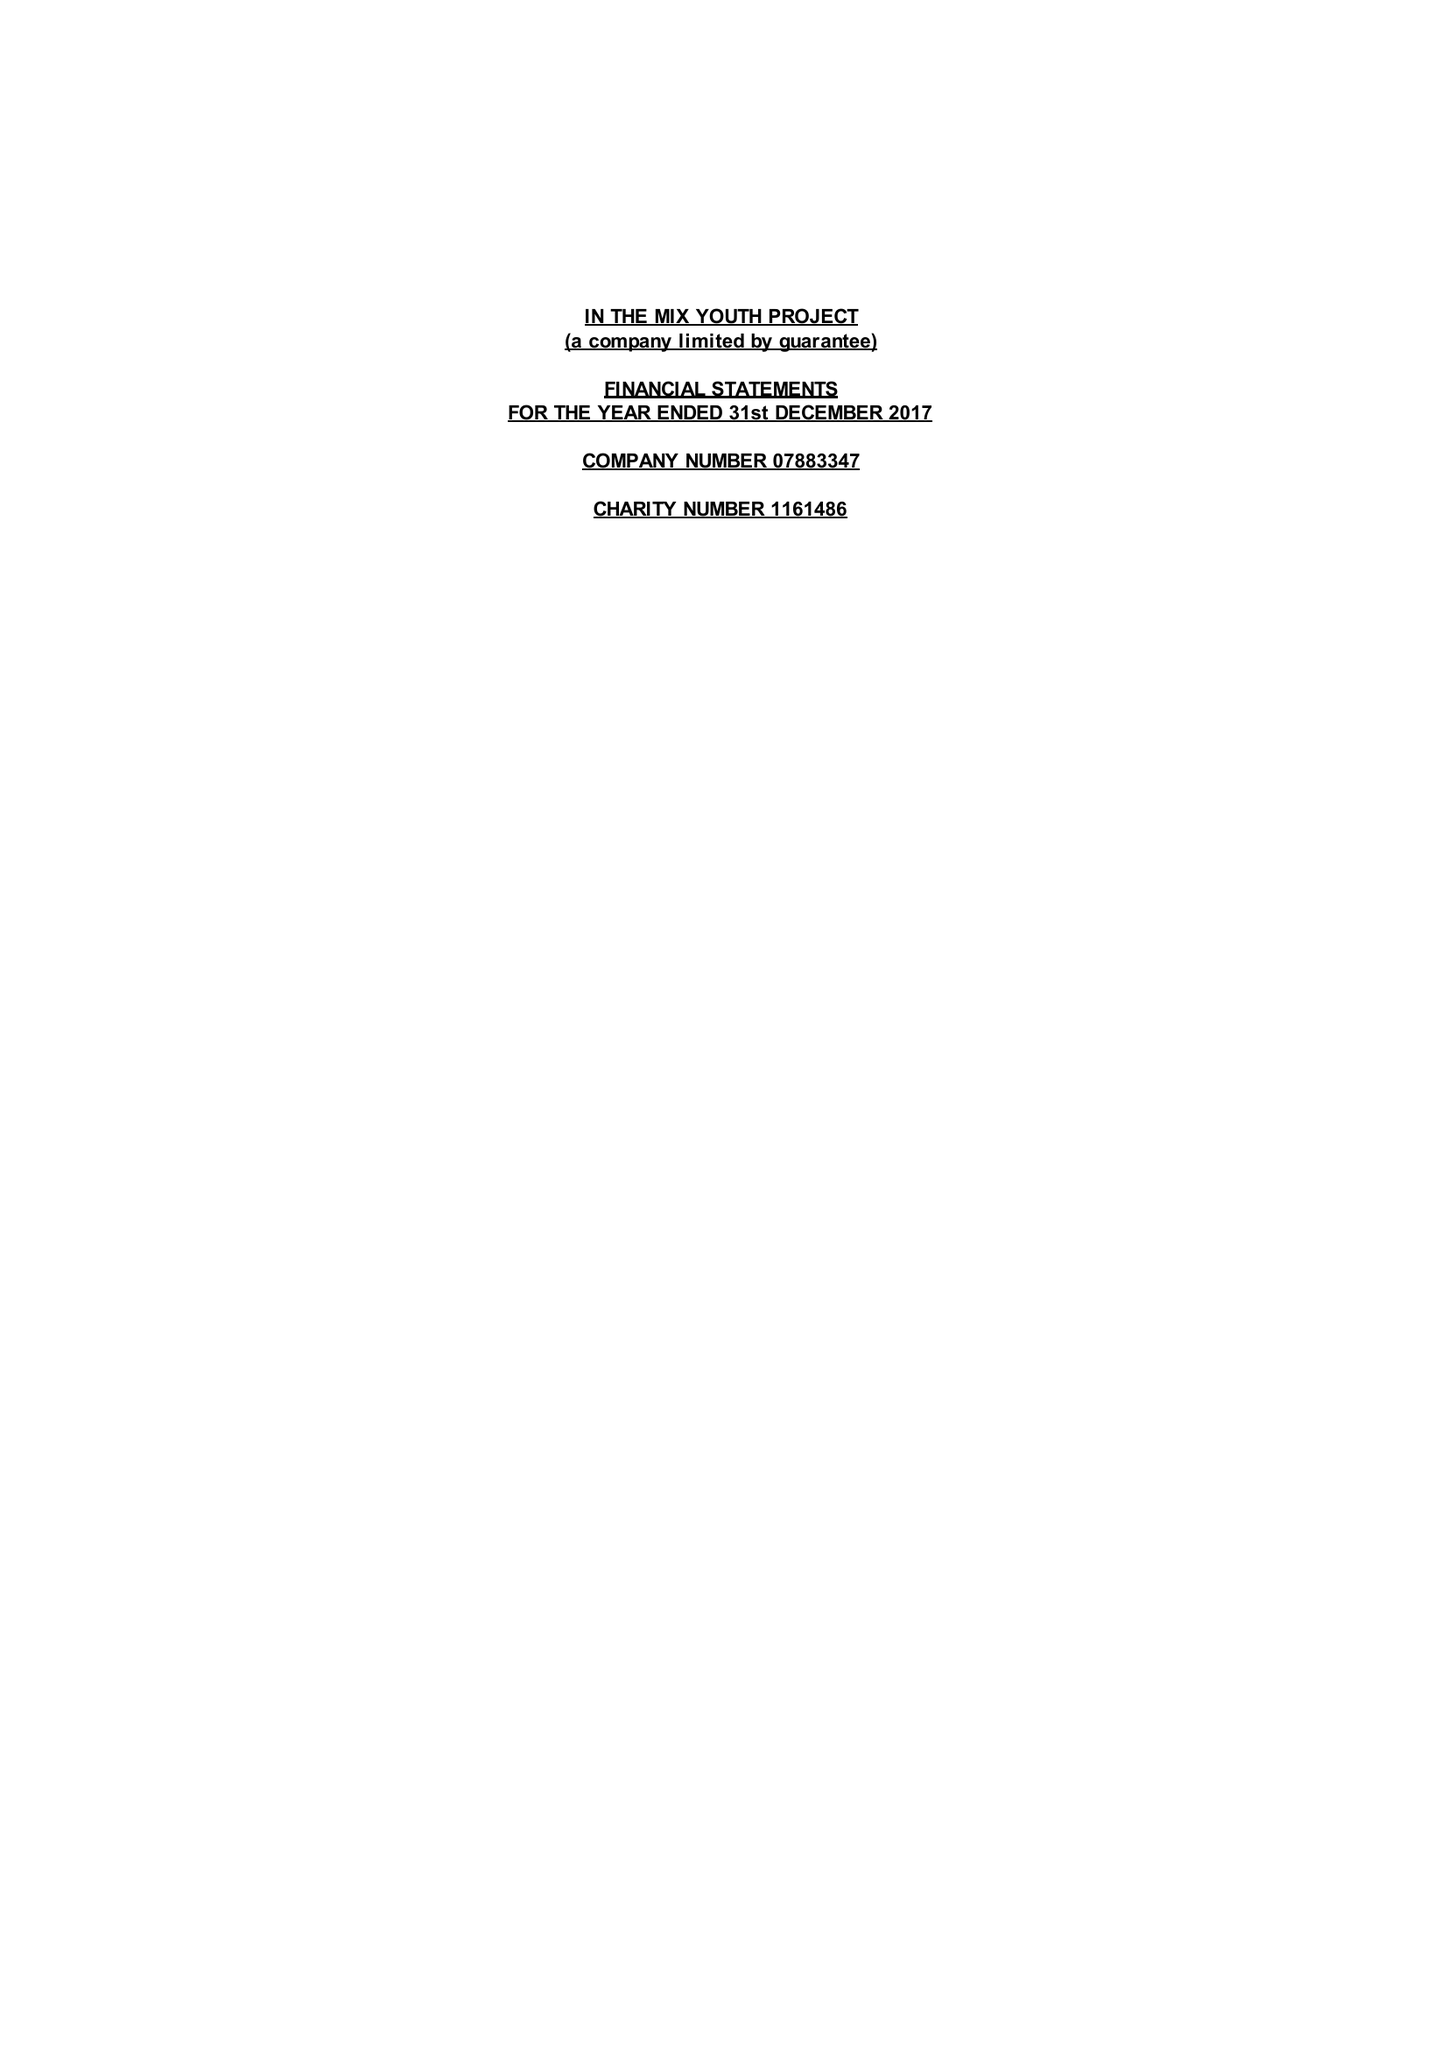What is the value for the charity_number?
Answer the question using a single word or phrase. 1161486 